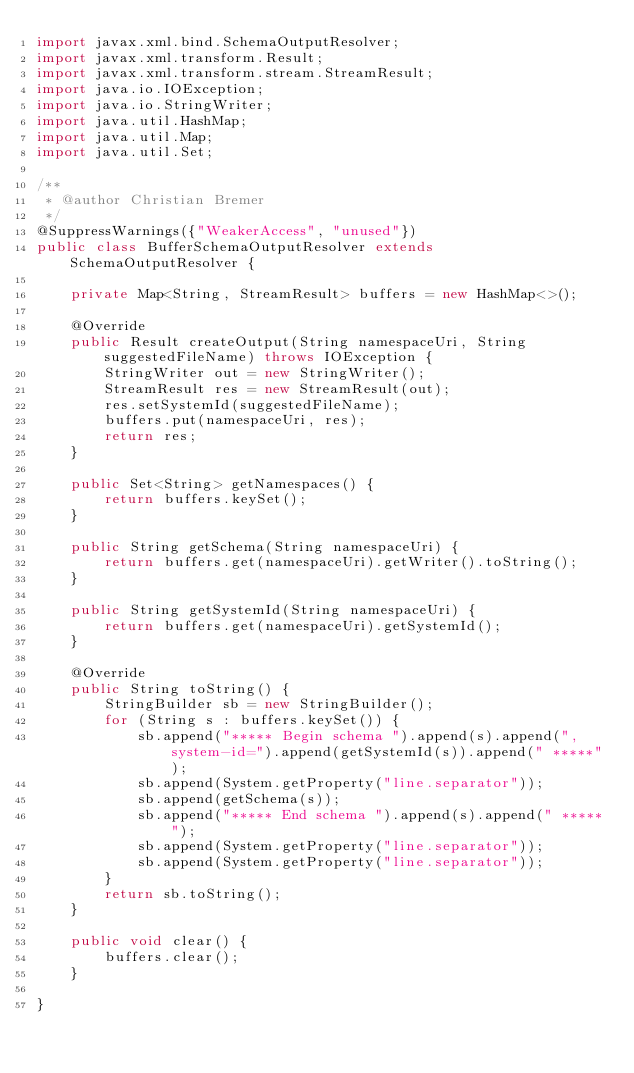Convert code to text. <code><loc_0><loc_0><loc_500><loc_500><_Java_>import javax.xml.bind.SchemaOutputResolver;
import javax.xml.transform.Result;
import javax.xml.transform.stream.StreamResult;
import java.io.IOException;
import java.io.StringWriter;
import java.util.HashMap;
import java.util.Map;
import java.util.Set;

/**
 * @author Christian Bremer
 */
@SuppressWarnings({"WeakerAccess", "unused"})
public class BufferSchemaOutputResolver extends SchemaOutputResolver {

    private Map<String, StreamResult> buffers = new HashMap<>();

    @Override
    public Result createOutput(String namespaceUri, String suggestedFileName) throws IOException {
        StringWriter out = new StringWriter();
        StreamResult res = new StreamResult(out);
        res.setSystemId(suggestedFileName);
        buffers.put(namespaceUri, res);
        return res;
    }

    public Set<String> getNamespaces() {
        return buffers.keySet();
    }

    public String getSchema(String namespaceUri) {
        return buffers.get(namespaceUri).getWriter().toString();
    }

    public String getSystemId(String namespaceUri) {
        return buffers.get(namespaceUri).getSystemId();
    }

    @Override
    public String toString() {
        StringBuilder sb = new StringBuilder();
        for (String s : buffers.keySet()) {
            sb.append("***** Begin schema ").append(s).append(", system-id=").append(getSystemId(s)).append(" *****");
            sb.append(System.getProperty("line.separator"));
            sb.append(getSchema(s));
            sb.append("***** End schema ").append(s).append(" *****");
            sb.append(System.getProperty("line.separator"));
            sb.append(System.getProperty("line.separator"));
        }
        return sb.toString();
    }

    public void clear() {
        buffers.clear();
    }

}
</code> 